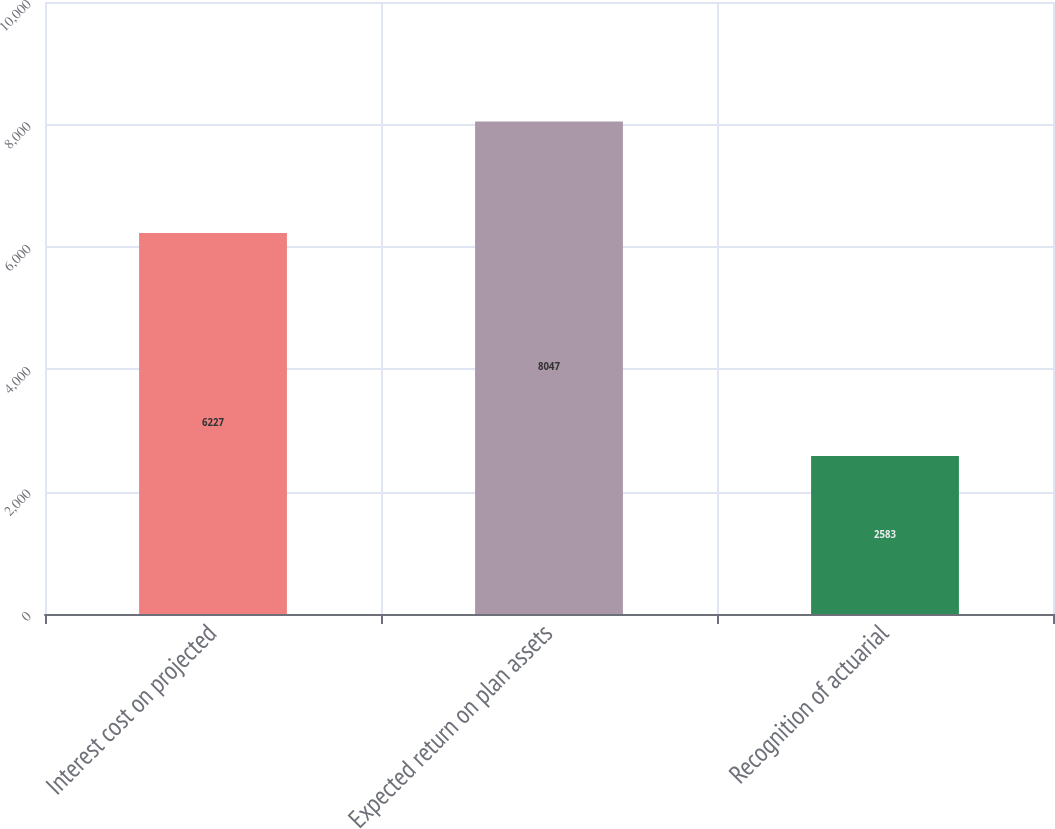Convert chart to OTSL. <chart><loc_0><loc_0><loc_500><loc_500><bar_chart><fcel>Interest cost on projected<fcel>Expected return on plan assets<fcel>Recognition of actuarial<nl><fcel>6227<fcel>8047<fcel>2583<nl></chart> 